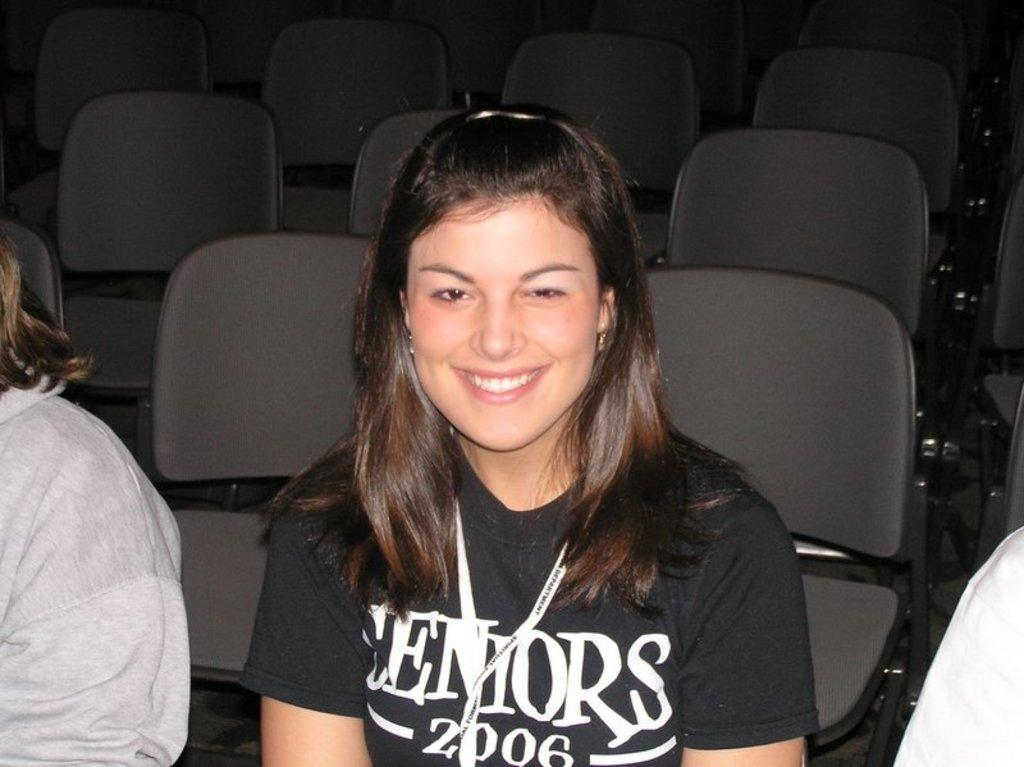How many people are in the image? There are three people in the image. What are the people doing in the image? The people are sitting on chairs. Can you describe the position of the woman in the image? The woman is sitting in the center. What is the facial expression of the woman in the image? The woman is smiling. Are there any other chairs visible in the image? Yes, there are additional chairs visible behind the people. What type of office furniture can be seen in the image? There is no office furniture present in the image; it features three people sitting on chairs. What day of the week is depicted in the image? The image does not provide any information about the day of the week. 